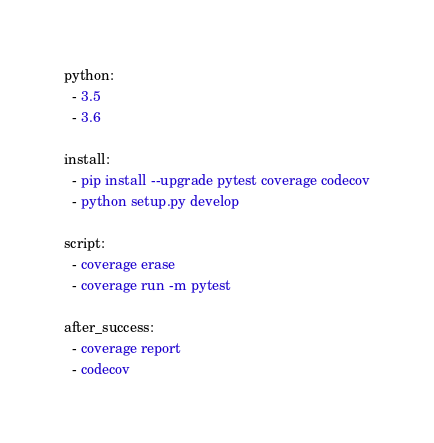<code> <loc_0><loc_0><loc_500><loc_500><_YAML_>python:
  - 3.5
  - 3.6

install:
  - pip install --upgrade pytest coverage codecov
  - python setup.py develop

script:
  - coverage erase
  - coverage run -m pytest

after_success:
  - coverage report
  - codecov
</code> 